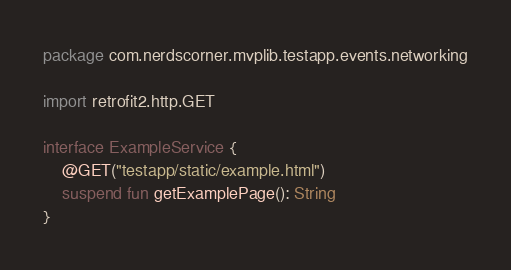<code> <loc_0><loc_0><loc_500><loc_500><_Kotlin_>package com.nerdscorner.mvplib.testapp.events.networking

import retrofit2.http.GET

interface ExampleService {
    @GET("testapp/static/example.html")
    suspend fun getExamplePage(): String
}
</code> 